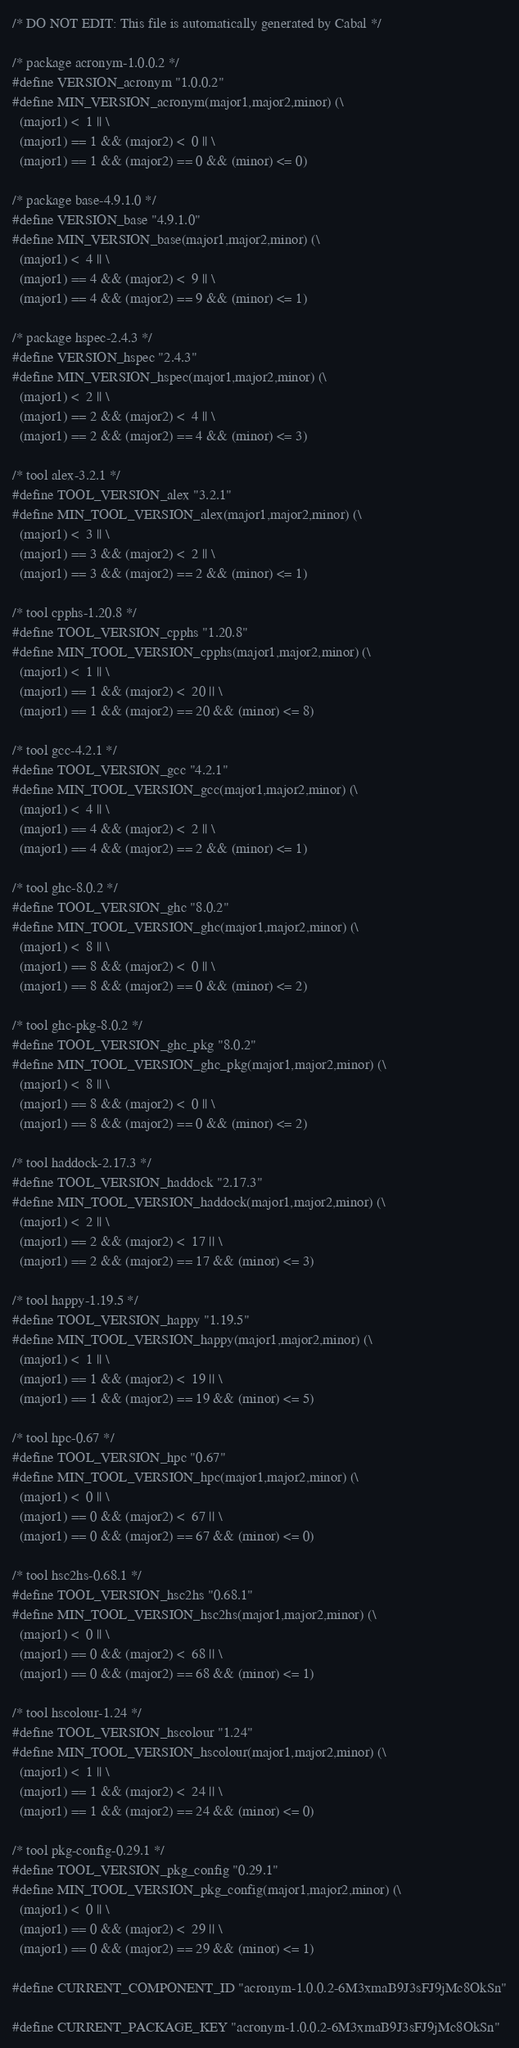Convert code to text. <code><loc_0><loc_0><loc_500><loc_500><_C_>/* DO NOT EDIT: This file is automatically generated by Cabal */

/* package acronym-1.0.0.2 */
#define VERSION_acronym "1.0.0.2"
#define MIN_VERSION_acronym(major1,major2,minor) (\
  (major1) <  1 || \
  (major1) == 1 && (major2) <  0 || \
  (major1) == 1 && (major2) == 0 && (minor) <= 0)

/* package base-4.9.1.0 */
#define VERSION_base "4.9.1.0"
#define MIN_VERSION_base(major1,major2,minor) (\
  (major1) <  4 || \
  (major1) == 4 && (major2) <  9 || \
  (major1) == 4 && (major2) == 9 && (minor) <= 1)

/* package hspec-2.4.3 */
#define VERSION_hspec "2.4.3"
#define MIN_VERSION_hspec(major1,major2,minor) (\
  (major1) <  2 || \
  (major1) == 2 && (major2) <  4 || \
  (major1) == 2 && (major2) == 4 && (minor) <= 3)

/* tool alex-3.2.1 */
#define TOOL_VERSION_alex "3.2.1"
#define MIN_TOOL_VERSION_alex(major1,major2,minor) (\
  (major1) <  3 || \
  (major1) == 3 && (major2) <  2 || \
  (major1) == 3 && (major2) == 2 && (minor) <= 1)

/* tool cpphs-1.20.8 */
#define TOOL_VERSION_cpphs "1.20.8"
#define MIN_TOOL_VERSION_cpphs(major1,major2,minor) (\
  (major1) <  1 || \
  (major1) == 1 && (major2) <  20 || \
  (major1) == 1 && (major2) == 20 && (minor) <= 8)

/* tool gcc-4.2.1 */
#define TOOL_VERSION_gcc "4.2.1"
#define MIN_TOOL_VERSION_gcc(major1,major2,minor) (\
  (major1) <  4 || \
  (major1) == 4 && (major2) <  2 || \
  (major1) == 4 && (major2) == 2 && (minor) <= 1)

/* tool ghc-8.0.2 */
#define TOOL_VERSION_ghc "8.0.2"
#define MIN_TOOL_VERSION_ghc(major1,major2,minor) (\
  (major1) <  8 || \
  (major1) == 8 && (major2) <  0 || \
  (major1) == 8 && (major2) == 0 && (minor) <= 2)

/* tool ghc-pkg-8.0.2 */
#define TOOL_VERSION_ghc_pkg "8.0.2"
#define MIN_TOOL_VERSION_ghc_pkg(major1,major2,minor) (\
  (major1) <  8 || \
  (major1) == 8 && (major2) <  0 || \
  (major1) == 8 && (major2) == 0 && (minor) <= 2)

/* tool haddock-2.17.3 */
#define TOOL_VERSION_haddock "2.17.3"
#define MIN_TOOL_VERSION_haddock(major1,major2,minor) (\
  (major1) <  2 || \
  (major1) == 2 && (major2) <  17 || \
  (major1) == 2 && (major2) == 17 && (minor) <= 3)

/* tool happy-1.19.5 */
#define TOOL_VERSION_happy "1.19.5"
#define MIN_TOOL_VERSION_happy(major1,major2,minor) (\
  (major1) <  1 || \
  (major1) == 1 && (major2) <  19 || \
  (major1) == 1 && (major2) == 19 && (minor) <= 5)

/* tool hpc-0.67 */
#define TOOL_VERSION_hpc "0.67"
#define MIN_TOOL_VERSION_hpc(major1,major2,minor) (\
  (major1) <  0 || \
  (major1) == 0 && (major2) <  67 || \
  (major1) == 0 && (major2) == 67 && (minor) <= 0)

/* tool hsc2hs-0.68.1 */
#define TOOL_VERSION_hsc2hs "0.68.1"
#define MIN_TOOL_VERSION_hsc2hs(major1,major2,minor) (\
  (major1) <  0 || \
  (major1) == 0 && (major2) <  68 || \
  (major1) == 0 && (major2) == 68 && (minor) <= 1)

/* tool hscolour-1.24 */
#define TOOL_VERSION_hscolour "1.24"
#define MIN_TOOL_VERSION_hscolour(major1,major2,minor) (\
  (major1) <  1 || \
  (major1) == 1 && (major2) <  24 || \
  (major1) == 1 && (major2) == 24 && (minor) <= 0)

/* tool pkg-config-0.29.1 */
#define TOOL_VERSION_pkg_config "0.29.1"
#define MIN_TOOL_VERSION_pkg_config(major1,major2,minor) (\
  (major1) <  0 || \
  (major1) == 0 && (major2) <  29 || \
  (major1) == 0 && (major2) == 29 && (minor) <= 1)

#define CURRENT_COMPONENT_ID "acronym-1.0.0.2-6M3xmaB9J3sFJ9jMc8OkSn"

#define CURRENT_PACKAGE_KEY "acronym-1.0.0.2-6M3xmaB9J3sFJ9jMc8OkSn"

</code> 